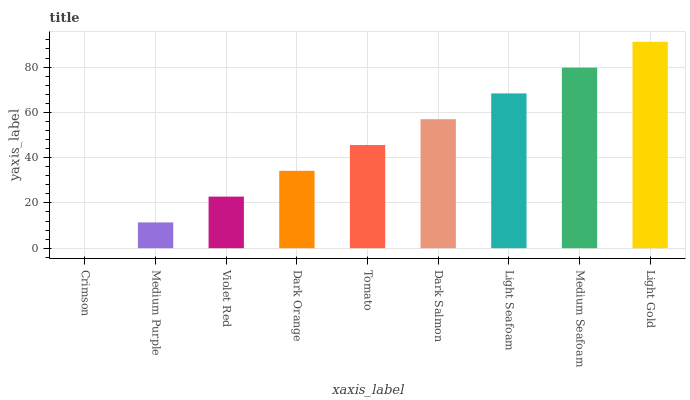Is Medium Purple the minimum?
Answer yes or no. No. Is Medium Purple the maximum?
Answer yes or no. No. Is Medium Purple greater than Crimson?
Answer yes or no. Yes. Is Crimson less than Medium Purple?
Answer yes or no. Yes. Is Crimson greater than Medium Purple?
Answer yes or no. No. Is Medium Purple less than Crimson?
Answer yes or no. No. Is Tomato the high median?
Answer yes or no. Yes. Is Tomato the low median?
Answer yes or no. Yes. Is Dark Salmon the high median?
Answer yes or no. No. Is Medium Seafoam the low median?
Answer yes or no. No. 